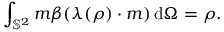<formula> <loc_0><loc_0><loc_500><loc_500>\int _ { \mathbb { S } ^ { 2 } } m \beta ( \lambda ( \rho ) \cdot m ) \, d \Omega = \rho .</formula> 